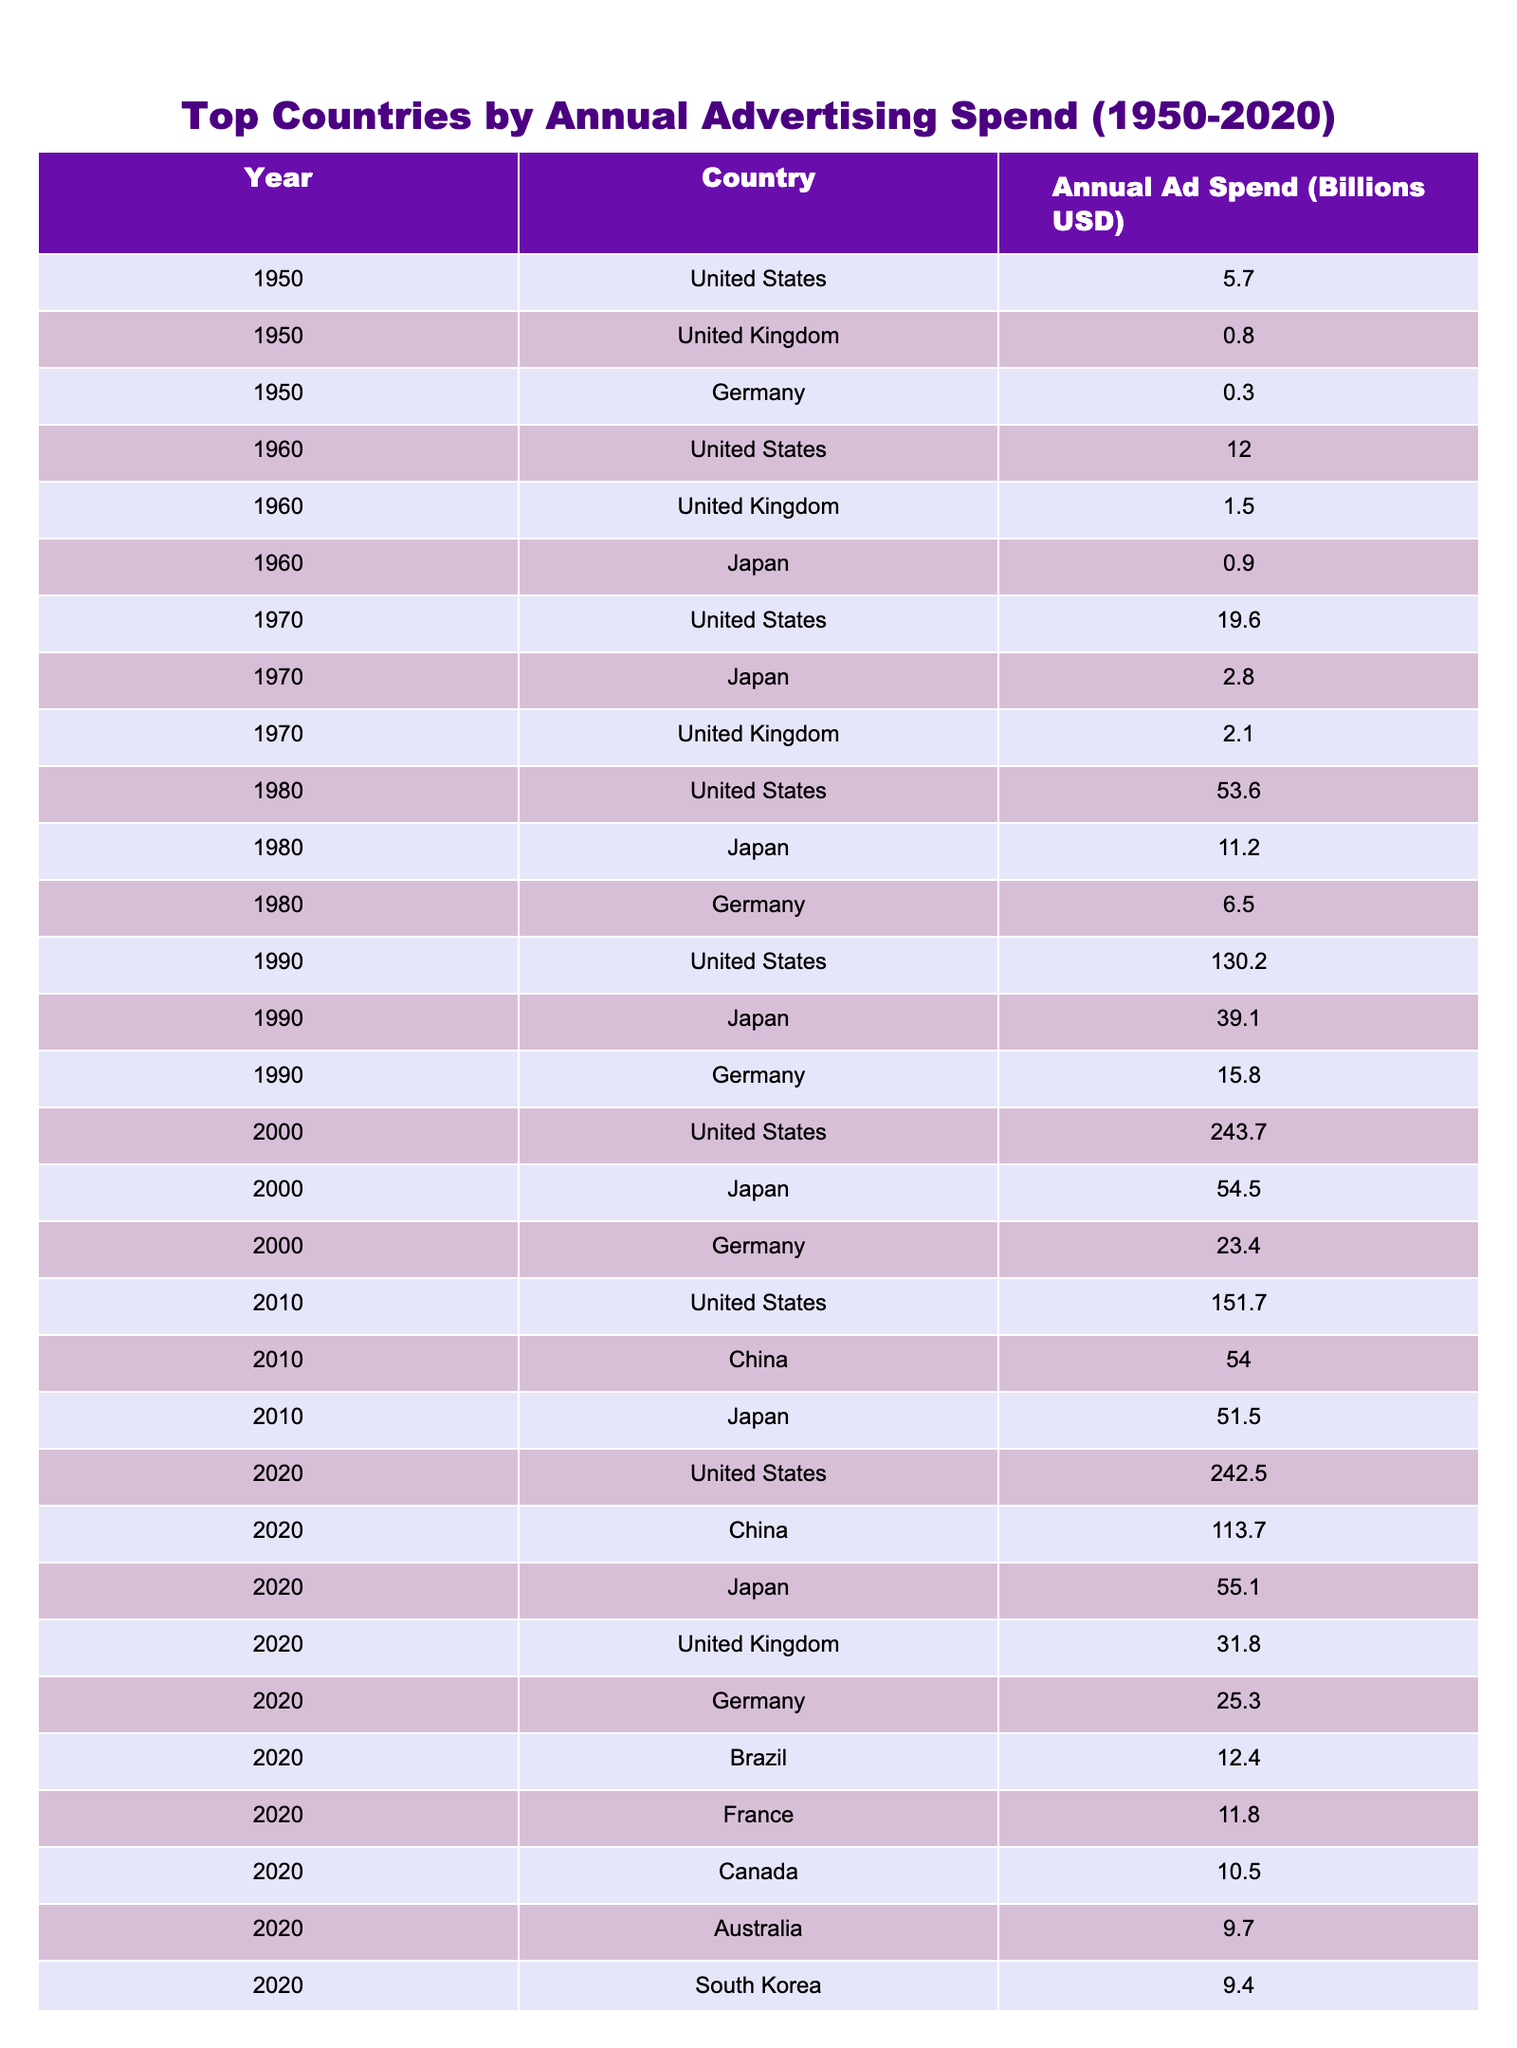What was the annual advertising spend of the United States in 1990? The table shows that in 1990, the Annual Ad Spend for the United States is listed as 130.2 billion USD.
Answer: 130.2 billion USD Which country had the highest advertising spend in 1980? According to the table, the country with the highest advertising spend in 1980 is the United States with 53.6 billion USD.
Answer: United States How much more did the United States spend on advertising in 2000 compared to Germany? In 2000, the United States spent 243.7 billion USD and Germany spent 23.4 billion USD. The difference is 243.7 - 23.4 = 220.3 billion USD.
Answer: 220.3 billion USD What was the average annual advertising spend for Japan from 1980 to 2020? The advertising spend for Japan from 1980 to 2020 is as follows: 11.2 (1980) + 39.1 (1990) + 54.5 (2000) + 51.5 (2010) + 55.1 (2020) = 211.4 billion USD. There are 5 years, so the average is 211.4 / 5 = 42.28 billion USD.
Answer: 42.28 billion USD Is it true that China had an advertising spend higher than 100 billion USD in 2020? The table indicates that China's advertising spend in 2020 was 113.7 billion USD, which is indeed higher than 100 billion USD.
Answer: Yes Which country showed the most significant increase in advertising spend from 1950 to 2020? The United States had an annual advertising spend of 5.7 billion USD in 1950, which increased to 242.5 billion USD in 2020, resulting in an increase of 236.8 billion USD, the highest among all listed countries.
Answer: United States What is the total advertising spend of the top three countries in 2010? The top three countries in 2010 are the United States (151.7 billion USD), China (54.0 billion USD), and Japan (51.5 billion USD). Summing these values gives a total of 151.7 + 54.0 + 51.5 = 257.2 billion USD.
Answer: 257.2 billion USD In which decade did Japan first exceed an advertising spend of 10 billion USD? Japan first exceeded 10 billion USD in the 1980s, with a spend of 11.2 billion USD in 1980, as seen in the table.
Answer: 1980s What percentage of total advertising spend did the United States account for in 1990 compared to the total spend of all listed countries that year? In 1990, the United States spent 130.2 billion USD. The total advertising spend for the listed countries was 130.2 (US) + 39.1 (Japan) + 15.8 (Germany) = 185.1 billion USD. The percentage is (130.2 / 185.1) * 100 = 70.3%.
Answer: 70.3% Which country consistently ranked among the top three in advertising spend from the 1980s to 2020? The United States is the only country that consistently ranked among the top three in advertising spend from the 1980s through 2020, as seen in the respective data points.
Answer: United States 